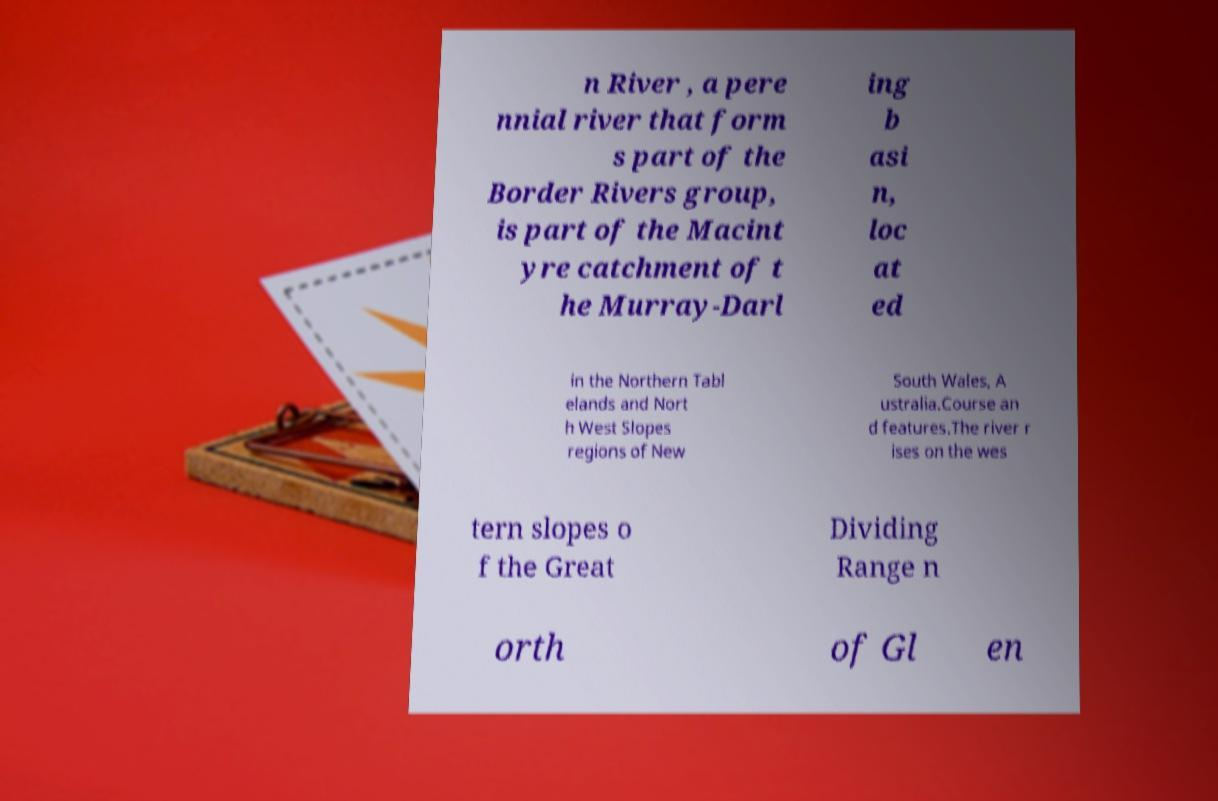Could you extract and type out the text from this image? n River , a pere nnial river that form s part of the Border Rivers group, is part of the Macint yre catchment of t he Murray-Darl ing b asi n, loc at ed in the Northern Tabl elands and Nort h West Slopes regions of New South Wales, A ustralia.Course an d features.The river r ises on the wes tern slopes o f the Great Dividing Range n orth of Gl en 